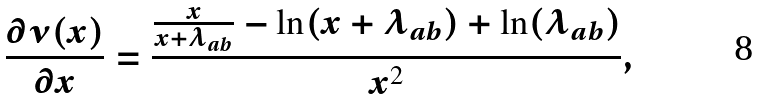<formula> <loc_0><loc_0><loc_500><loc_500>\frac { \partial \nu ( x ) } { \partial x } = \frac { \frac { x } { x + \lambda _ { a b } } - \ln ( x + \lambda _ { a b } ) + \ln ( \lambda _ { a b } ) } { x ^ { 2 } } ,</formula> 